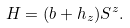<formula> <loc_0><loc_0><loc_500><loc_500>H = ( b + h _ { z } ) S ^ { z } .</formula> 